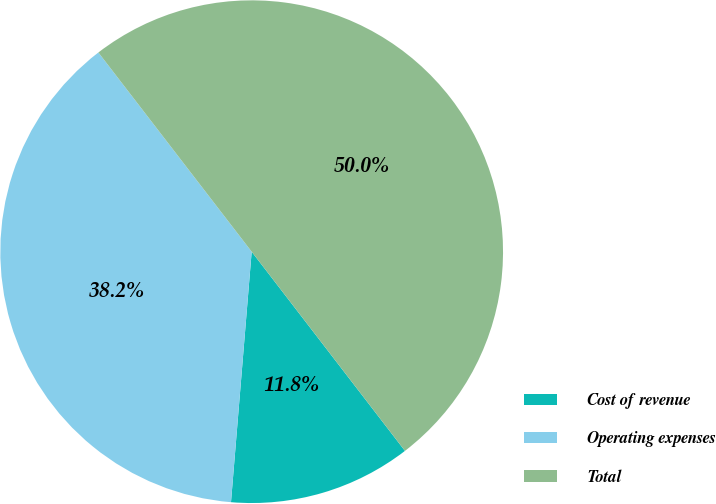Convert chart. <chart><loc_0><loc_0><loc_500><loc_500><pie_chart><fcel>Cost of revenue<fcel>Operating expenses<fcel>Total<nl><fcel>11.75%<fcel>38.25%<fcel>50.0%<nl></chart> 